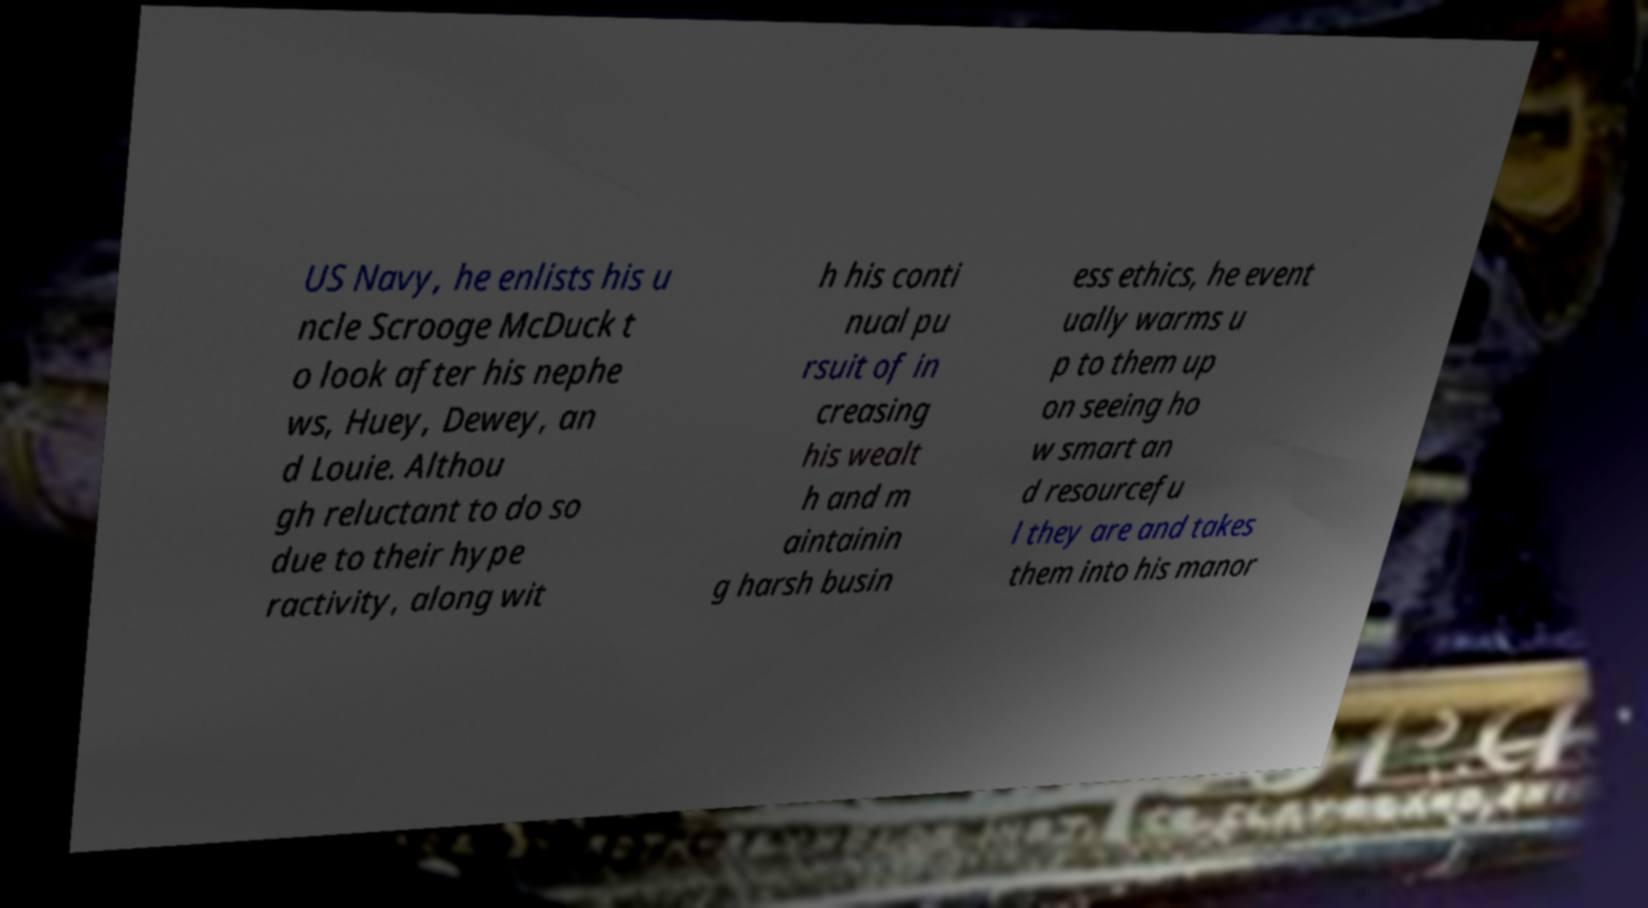There's text embedded in this image that I need extracted. Can you transcribe it verbatim? US Navy, he enlists his u ncle Scrooge McDuck t o look after his nephe ws, Huey, Dewey, an d Louie. Althou gh reluctant to do so due to their hype ractivity, along wit h his conti nual pu rsuit of in creasing his wealt h and m aintainin g harsh busin ess ethics, he event ually warms u p to them up on seeing ho w smart an d resourcefu l they are and takes them into his manor 